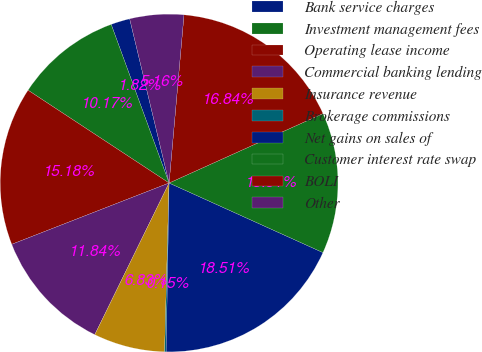Convert chart. <chart><loc_0><loc_0><loc_500><loc_500><pie_chart><fcel>Bank service charges<fcel>Investment management fees<fcel>Operating lease income<fcel>Commercial banking lending<fcel>Insurance revenue<fcel>Brokerage commissions<fcel>Net gains on sales of<fcel>Customer interest rate swap<fcel>BOLI<fcel>Other<nl><fcel>1.82%<fcel>10.17%<fcel>15.18%<fcel>11.84%<fcel>6.83%<fcel>0.15%<fcel>18.52%<fcel>13.51%<fcel>16.85%<fcel>5.16%<nl></chart> 